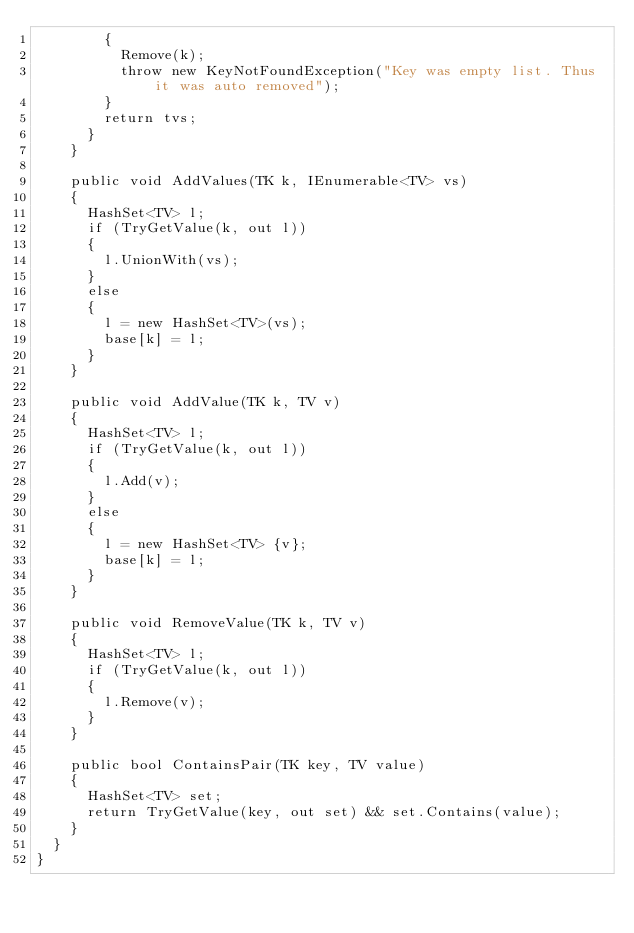<code> <loc_0><loc_0><loc_500><loc_500><_C#_>        {
          Remove(k);
          throw new KeyNotFoundException("Key was empty list. Thus it was auto removed");
        }
        return tvs;
      }
    }

    public void AddValues(TK k, IEnumerable<TV> vs)
    {
      HashSet<TV> l;
      if (TryGetValue(k, out l))
      {
        l.UnionWith(vs);
      }
      else
      {
        l = new HashSet<TV>(vs);
        base[k] = l;
      }
    }

    public void AddValue(TK k, TV v)
    {
      HashSet<TV> l;
      if (TryGetValue(k, out l))
      {
        l.Add(v);
      }
      else
      {
        l = new HashSet<TV> {v};
        base[k] = l;
      }
    }

    public void RemoveValue(TK k, TV v)
    {
      HashSet<TV> l;
      if (TryGetValue(k, out l))
      {
        l.Remove(v);
      }      
    }

    public bool ContainsPair(TK key, TV value)
    {
      HashSet<TV> set;
      return TryGetValue(key, out set) && set.Contains(value);
    }
  }
}</code> 